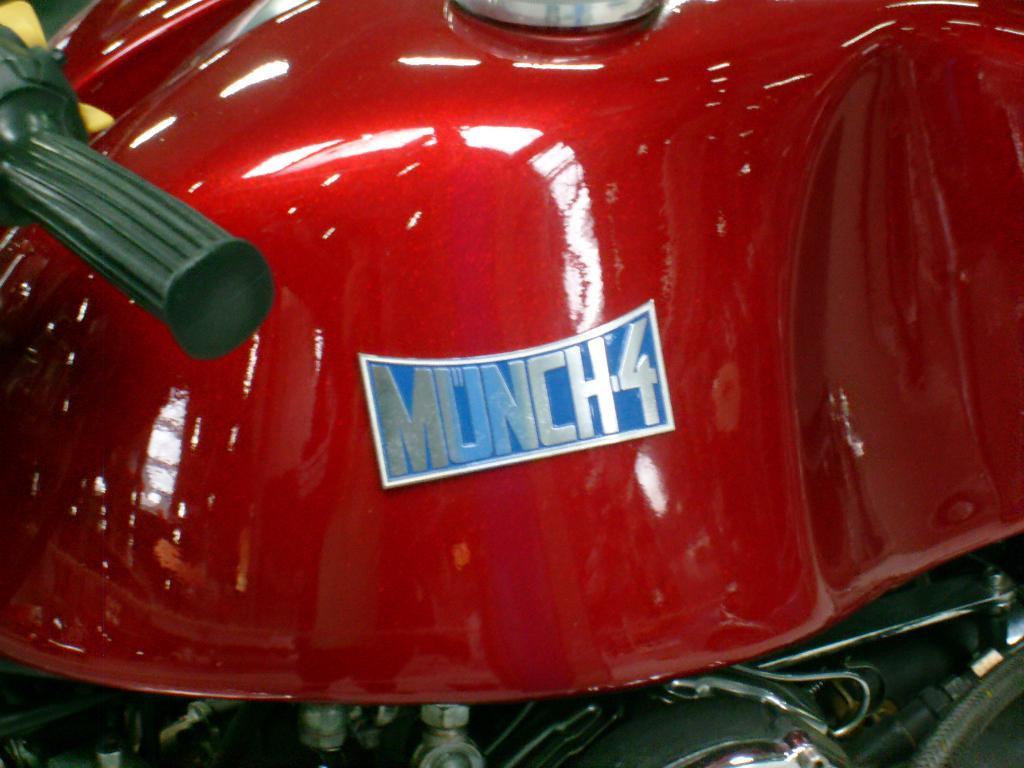In one or two sentences, can you explain what this image depicts? In this image we can see some part of a vehicle which is in red color and there is a board which is attached to it and written as munch4. 